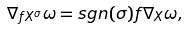Convert formula to latex. <formula><loc_0><loc_0><loc_500><loc_500>\nabla _ { f X ^ { \sigma } } \omega = s g n ( \sigma ) f \nabla _ { X } \omega ,</formula> 